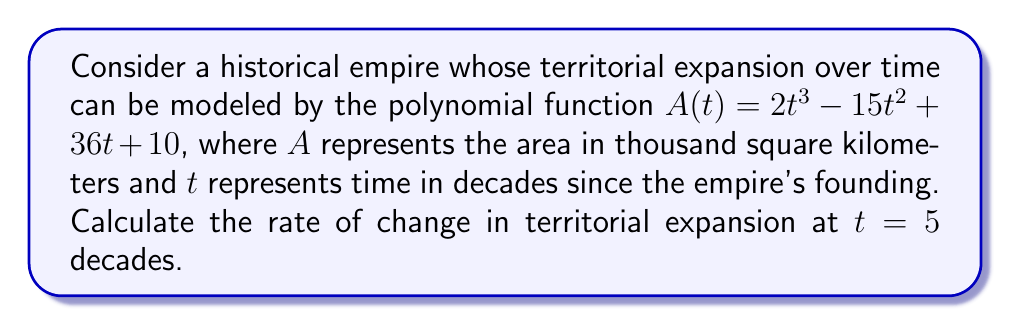Show me your answer to this math problem. To solve this problem, we need to follow these steps:

1) The rate of change in territorial expansion is represented by the derivative of the area function $A(t)$.

2) Let's find the derivative $A'(t)$ using the power rule:
   $$A'(t) = \frac{d}{dt}(2t^3 - 15t^2 + 36t + 10)$$
   $$A'(t) = 6t^2 - 30t + 36$$

3) Now that we have the rate of change function, we need to evaluate it at $t = 5$:
   $$A'(5) = 6(5^2) - 30(5) + 36$$
   $$A'(5) = 6(25) - 150 + 36$$
   $$A'(5) = 150 - 150 + 36$$
   $$A'(5) = 36$$

4) Interpret the result: At $t = 5$ decades, the rate of territorial expansion is 36 thousand square kilometers per decade.

This problem relates to the persona of a history professor by framing the mathematical concept in terms of historical territorial expansion, which is a key aspect of political history and the processes of fragmentation and integration.
Answer: 36 thousand km²/decade 